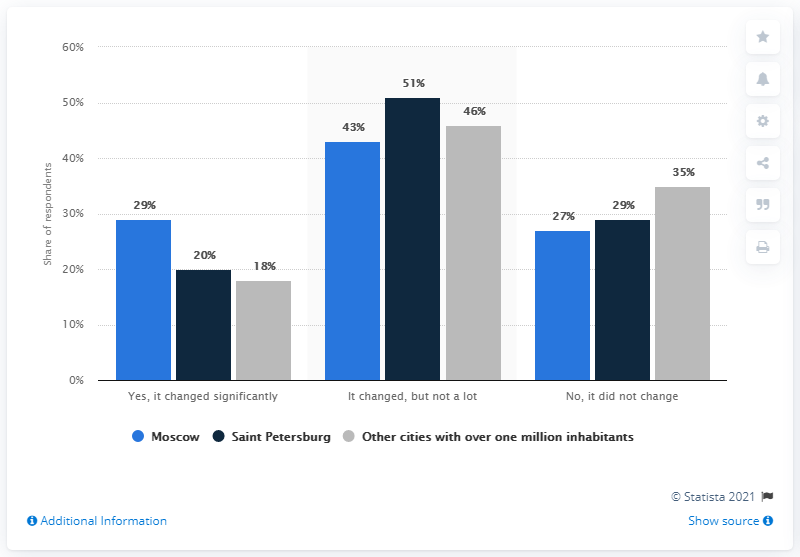Draw attention to some important aspects in this diagram. It is Saint Petersburg that has the highest total in 'it changed, but not a lot'. According to the survey results from Saint Petersburg, 51% of respondents shared this view. The average response from all Moscow participants is 33. 